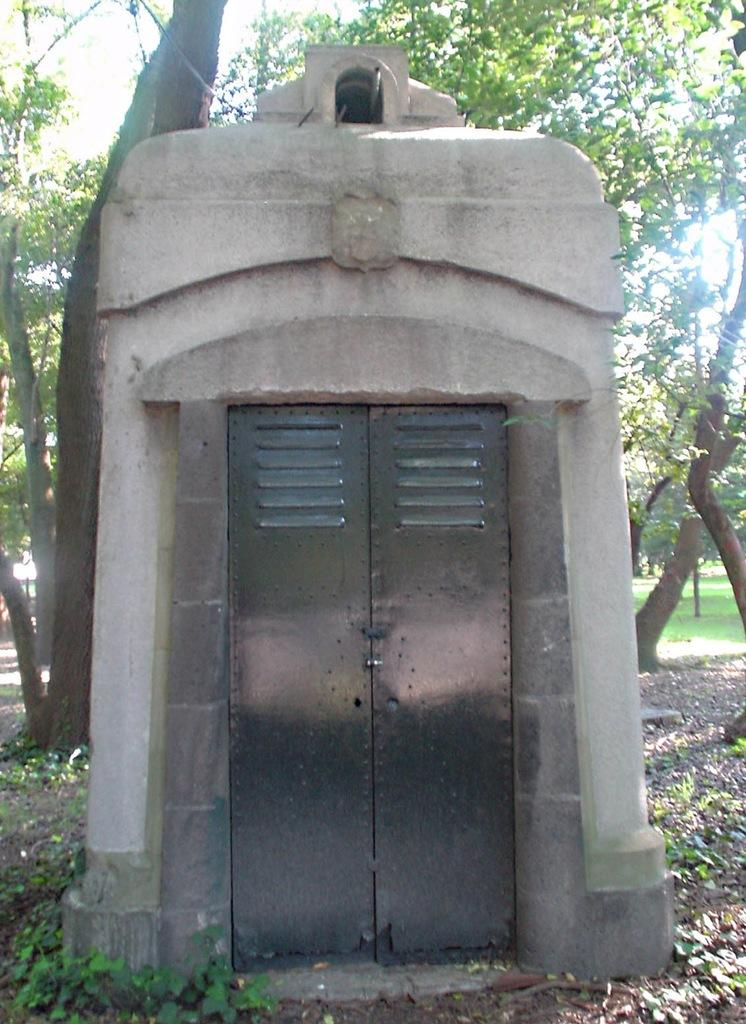What type of house is shown in the image? There is a concrete construction house in the image. What material is the door of the house made of? The door of the house is made of metal. What can be seen in the background of the image? There are trees visible in the background of the image. What color is the sock hanging on the dock in the image? There is no sock or dock present in the image. 